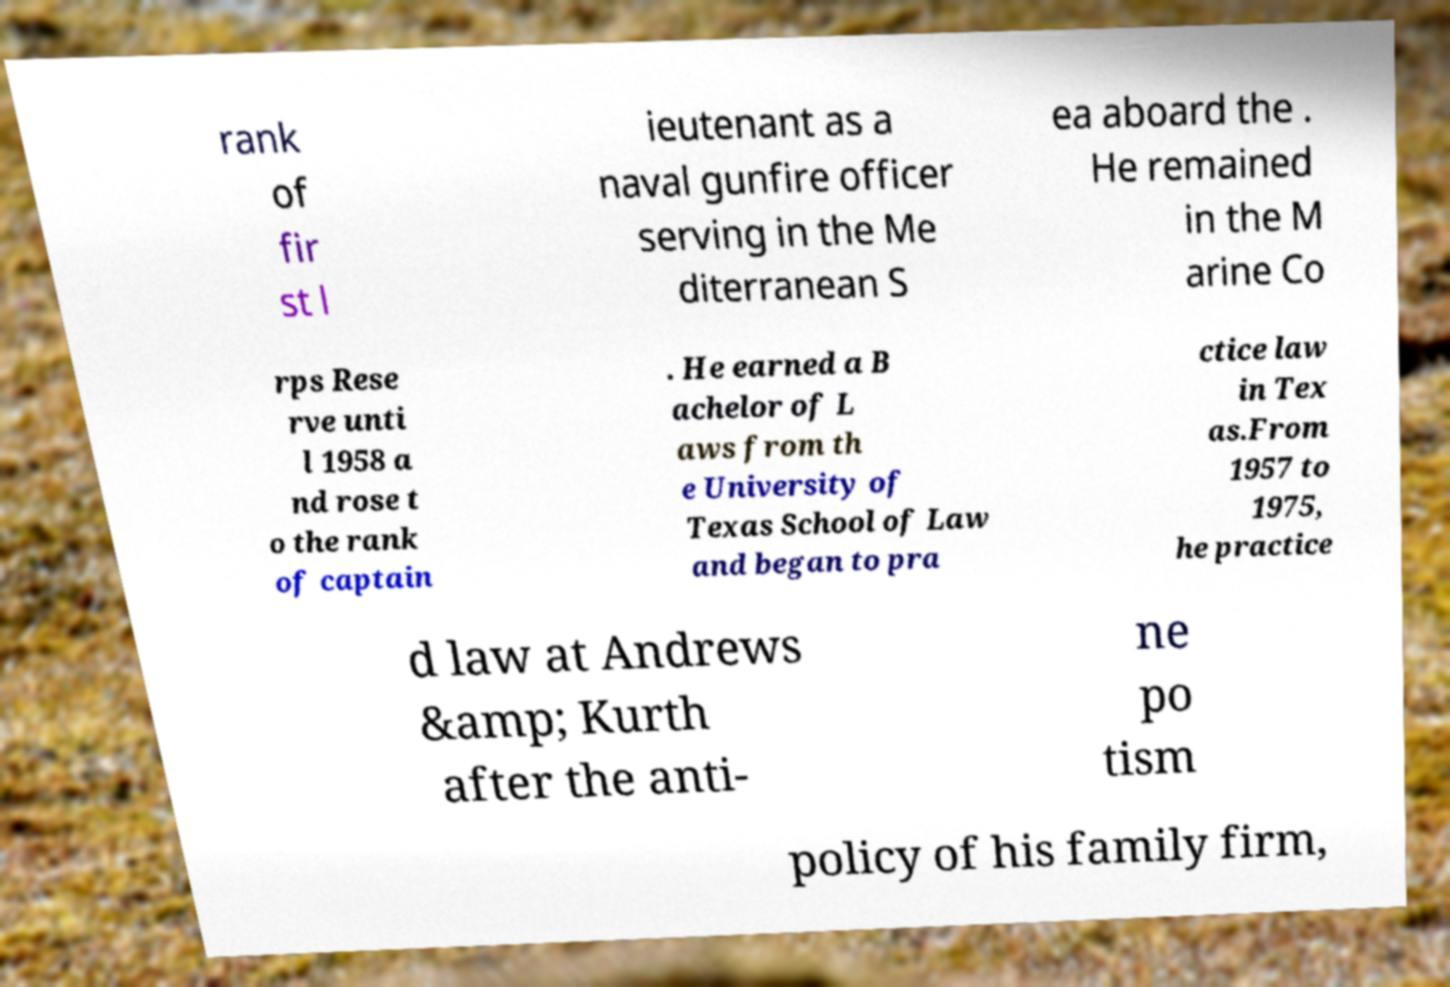Please read and relay the text visible in this image. What does it say? rank of fir st l ieutenant as a naval gunfire officer serving in the Me diterranean S ea aboard the . He remained in the M arine Co rps Rese rve unti l 1958 a nd rose t o the rank of captain . He earned a B achelor of L aws from th e University of Texas School of Law and began to pra ctice law in Tex as.From 1957 to 1975, he practice d law at Andrews &amp; Kurth after the anti- ne po tism policy of his family firm, 